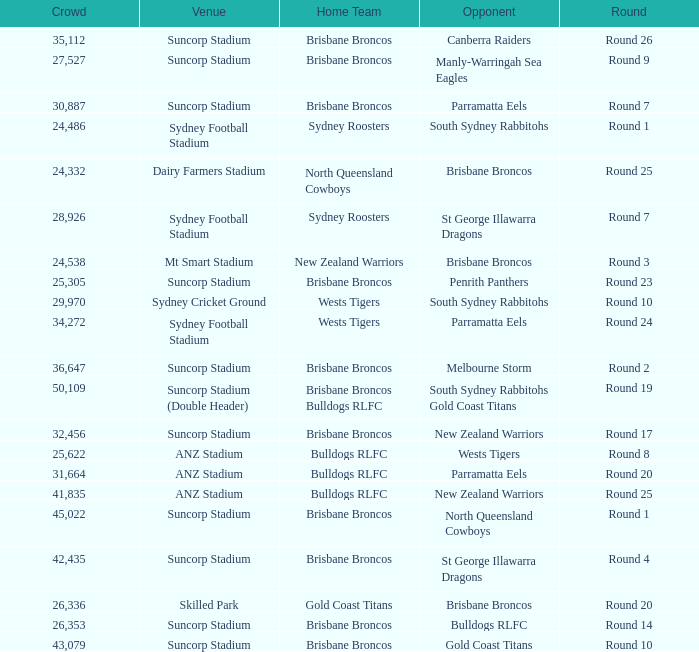Parse the table in full. {'header': ['Crowd', 'Venue', 'Home Team', 'Opponent', 'Round'], 'rows': [['35,112', 'Suncorp Stadium', 'Brisbane Broncos', 'Canberra Raiders', 'Round 26'], ['27,527', 'Suncorp Stadium', 'Brisbane Broncos', 'Manly-Warringah Sea Eagles', 'Round 9'], ['30,887', 'Suncorp Stadium', 'Brisbane Broncos', 'Parramatta Eels', 'Round 7'], ['24,486', 'Sydney Football Stadium', 'Sydney Roosters', 'South Sydney Rabbitohs', 'Round 1'], ['24,332', 'Dairy Farmers Stadium', 'North Queensland Cowboys', 'Brisbane Broncos', 'Round 25'], ['28,926', 'Sydney Football Stadium', 'Sydney Roosters', 'St George Illawarra Dragons', 'Round 7'], ['24,538', 'Mt Smart Stadium', 'New Zealand Warriors', 'Brisbane Broncos', 'Round 3'], ['25,305', 'Suncorp Stadium', 'Brisbane Broncos', 'Penrith Panthers', 'Round 23'], ['29,970', 'Sydney Cricket Ground', 'Wests Tigers', 'South Sydney Rabbitohs', 'Round 10'], ['34,272', 'Sydney Football Stadium', 'Wests Tigers', 'Parramatta Eels', 'Round 24'], ['36,647', 'Suncorp Stadium', 'Brisbane Broncos', 'Melbourne Storm', 'Round 2'], ['50,109', 'Suncorp Stadium (Double Header)', 'Brisbane Broncos Bulldogs RLFC', 'South Sydney Rabbitohs Gold Coast Titans', 'Round 19'], ['32,456', 'Suncorp Stadium', 'Brisbane Broncos', 'New Zealand Warriors', 'Round 17'], ['25,622', 'ANZ Stadium', 'Bulldogs RLFC', 'Wests Tigers', 'Round 8'], ['31,664', 'ANZ Stadium', 'Bulldogs RLFC', 'Parramatta Eels', 'Round 20'], ['41,835', 'ANZ Stadium', 'Bulldogs RLFC', 'New Zealand Warriors', 'Round 25'], ['45,022', 'Suncorp Stadium', 'Brisbane Broncos', 'North Queensland Cowboys', 'Round 1'], ['42,435', 'Suncorp Stadium', 'Brisbane Broncos', 'St George Illawarra Dragons', 'Round 4'], ['26,336', 'Skilled Park', 'Gold Coast Titans', 'Brisbane Broncos', 'Round 20'], ['26,353', 'Suncorp Stadium', 'Brisbane Broncos', 'Bulldogs RLFC', 'Round 14'], ['43,079', 'Suncorp Stadium', 'Brisbane Broncos', 'Gold Coast Titans', 'Round 10']]} What was the attendance at Round 9? 1.0. 